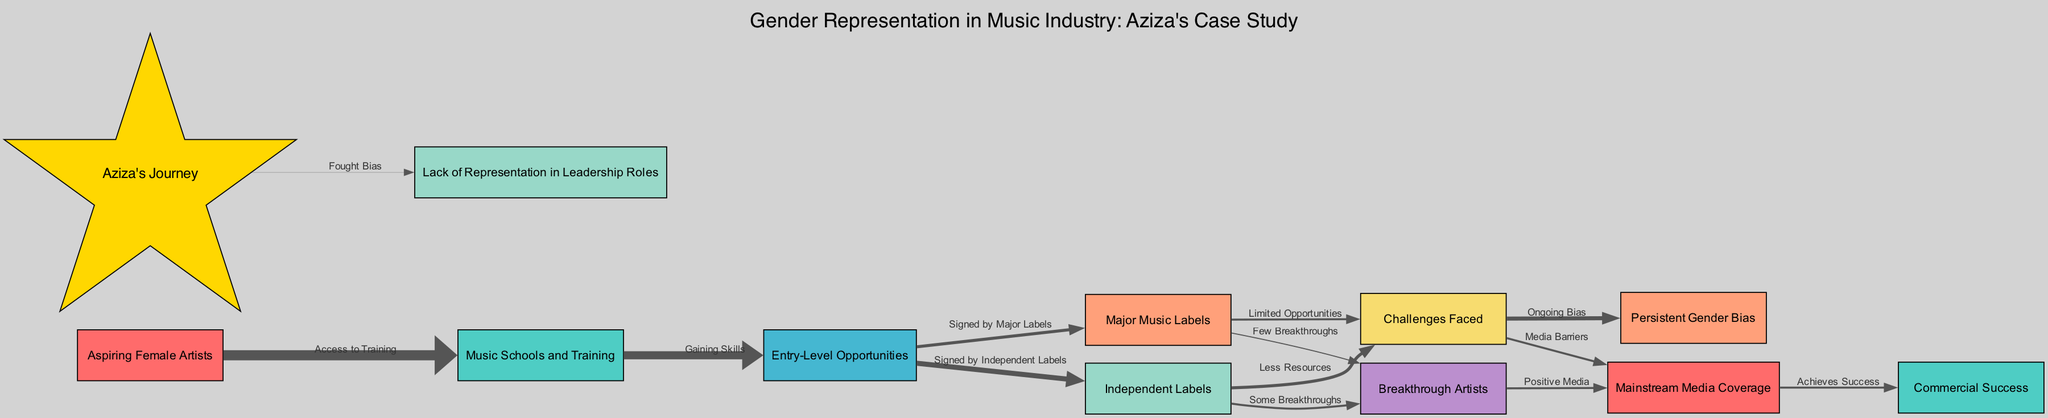What is the total number of nodes in the diagram? The diagram lists the following nodes: Aspiring Female Artists, Music Schools and Training, Entry-Level Opportunities, Major Music Labels, Independent Labels, Challenges Faced, Breakthrough Artists, Mainstream Media Coverage, Commercial Success, Aziza's Journey, Persistent Gender Bias, Lack of Representation in Leadership Roles. Counting these nodes gives a total of 12.
Answer: 12 How many edges lead from "Entry-Level Opportunities"? The node "Entry-Level Opportunities" connects to two different targets: "Major Music Labels" and "Independent Labels". Therefore, there are two edges leading from this node.
Answer: 2 What value represents the "Signed by Major Labels" connection? The flow from "Entry-Level Opportunities" to "Major Music Labels" indicates a value of 15, reflecting the number of aspiring female artists who find opportunities with major labels.
Answer: 15 Which node directly addresses "Ongoing Bias"? The node "Challenges Faced" connects to "Persistent Gender Bias" with a flow of 20, indicating that it directly addresses ongoing bias that women artists face in the music industry.
Answer: Persistent Gender Bias What does Aziza's journey represent in relation to leadership roles? Aziza's Journey connects to "Lack of Representation in Leadership Roles", with a value of 1 indicating her fight against bias in a sector with limited female leaders.
Answer: Fought Bias How many breakthroughs are there from Independent Labels? The "Independent Labels" node has an outgoing connection to "Breakthrough Artists" with a flow of 10, showing that some artists signed by independent labels achieve breakthroughs.
Answer: 10 What percentage of aspiring female artists access training? The edge from "Aspiring Female Artists" to "Music Schools and Training" shows a flow of 50 out of a theoretical total of 100 aspiring artists, indicating that 50% access training.
Answer: 50% How does media coverage affect commercial success? The flow from "Mainstream Media Coverage" to "Commercial Success" reveals a value of 10, suggesting that positive media coverage plays a key role in achieving commercial success for artists.
Answer: Achieves Success Which node experiences less resources? The edge from "Independent Labels" to "Challenges Faced" shows a value of 15, indicating that artists signed to independent labels tend to face challenges due to less available resources.
Answer: Less Resources 